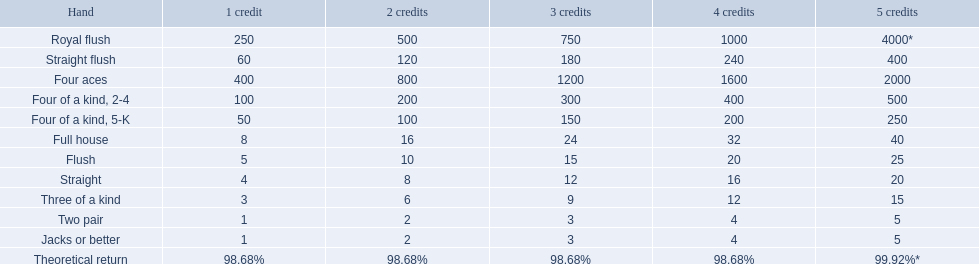What are the 5 best kinds of hand for victory? Royal flush, Straight flush, Four aces, Four of a kind, 2-4, Four of a kind, 5-K. Between those 5, which of those hands are a quartet? Four of a kind, 2-4, Four of a kind, 5-K. Of those 2 hands, which is the supreme kind of quartet for winning? Four of a kind, 2-4. 